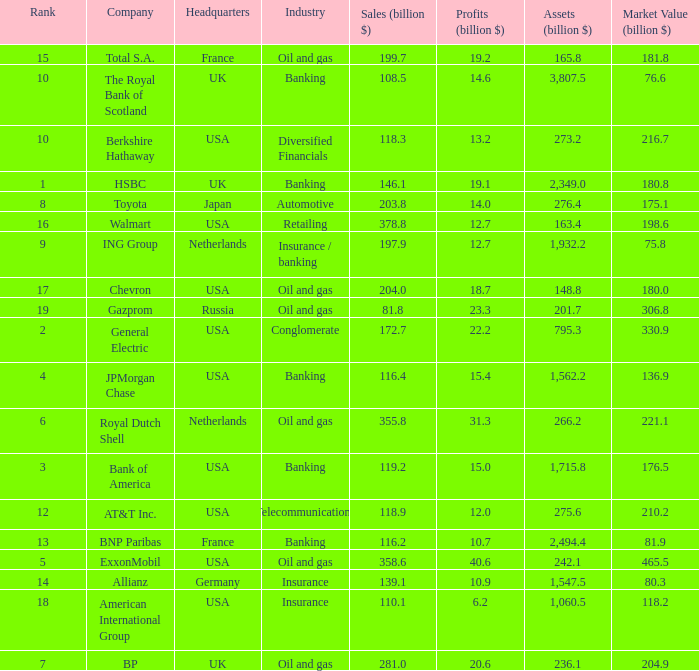Can you give me this table as a dict? {'header': ['Rank', 'Company', 'Headquarters', 'Industry', 'Sales (billion $)', 'Profits (billion $)', 'Assets (billion $)', 'Market Value (billion $)'], 'rows': [['15', 'Total S.A.', 'France', 'Oil and gas', '199.7', '19.2', '165.8', '181.8'], ['10', 'The Royal Bank of Scotland', 'UK', 'Banking', '108.5', '14.6', '3,807.5', '76.6'], ['10', 'Berkshire Hathaway', 'USA', 'Diversified Financials', '118.3', '13.2', '273.2', '216.7'], ['1', 'HSBC', 'UK', 'Banking', '146.1', '19.1', '2,349.0', '180.8'], ['8', 'Toyota', 'Japan', 'Automotive', '203.8', '14.0', '276.4', '175.1'], ['16', 'Walmart', 'USA', 'Retailing', '378.8', '12.7', '163.4', '198.6'], ['9', 'ING Group', 'Netherlands', 'Insurance / banking', '197.9', '12.7', '1,932.2', '75.8'], ['17', 'Chevron', 'USA', 'Oil and gas', '204.0', '18.7', '148.8', '180.0'], ['19', 'Gazprom', 'Russia', 'Oil and gas', '81.8', '23.3', '201.7', '306.8'], ['2', 'General Electric', 'USA', 'Conglomerate', '172.7', '22.2', '795.3', '330.9'], ['4', 'JPMorgan Chase', 'USA', 'Banking', '116.4', '15.4', '1,562.2', '136.9'], ['6', 'Royal Dutch Shell', 'Netherlands', 'Oil and gas', '355.8', '31.3', '266.2', '221.1'], ['3', 'Bank of America', 'USA', 'Banking', '119.2', '15.0', '1,715.8', '176.5'], ['12', 'AT&T Inc.', 'USA', 'Telecommunications', '118.9', '12.0', '275.6', '210.2'], ['13', 'BNP Paribas', 'France', 'Banking', '116.2', '10.7', '2,494.4', '81.9'], ['5', 'ExxonMobil', 'USA', 'Oil and gas', '358.6', '40.6', '242.1', '465.5'], ['14', 'Allianz', 'Germany', 'Insurance', '139.1', '10.9', '1,547.5', '80.3'], ['18', 'American International Group', 'USA', 'Insurance', '110.1', '6.2', '1,060.5', '118.2'], ['7', 'BP', 'UK', 'Oil and gas', '281.0', '20.6', '236.1', '204.9']]} What is the market value of a company in billions that has 172.7 billion in sales?  330.9. 